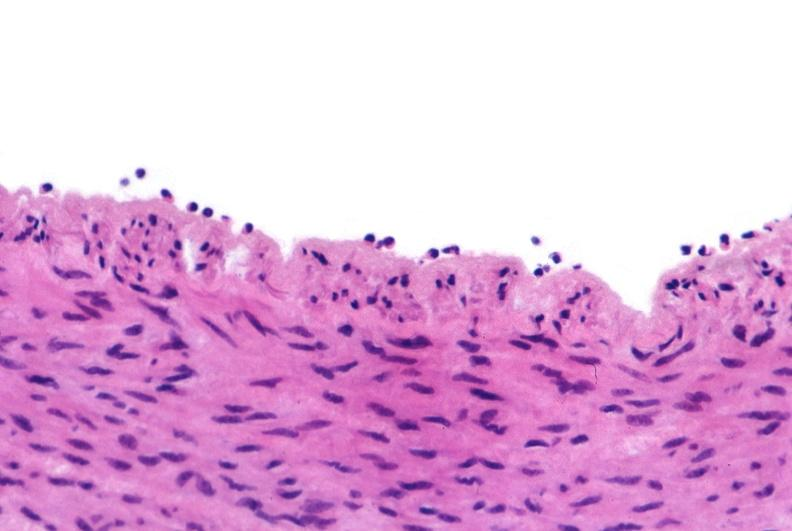does this image show acute inflammation, rolling leukocytes polymorphonuclear neutrophils?
Answer the question using a single word or phrase. Yes 